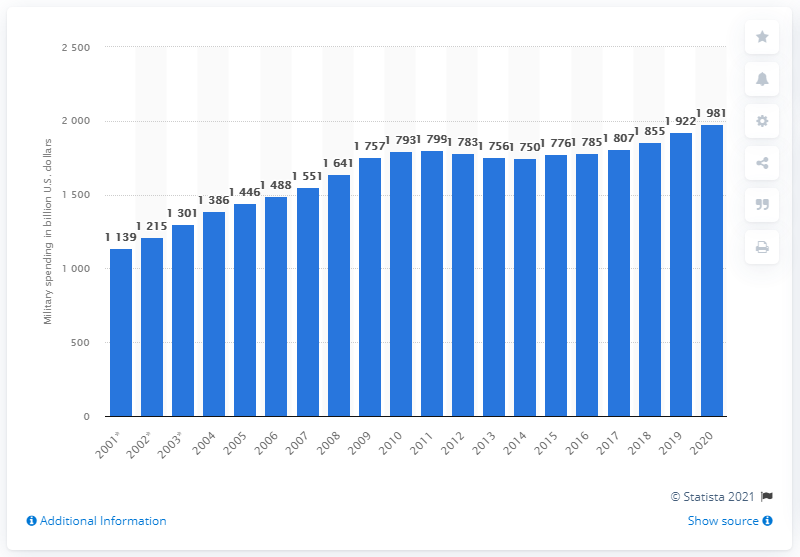Draw attention to some important aspects in this diagram. In 2020, the global military spending was $1.75 trillion. This is an increase from $1.24 trillion in 1981. In 2001, military spending was 1139. 